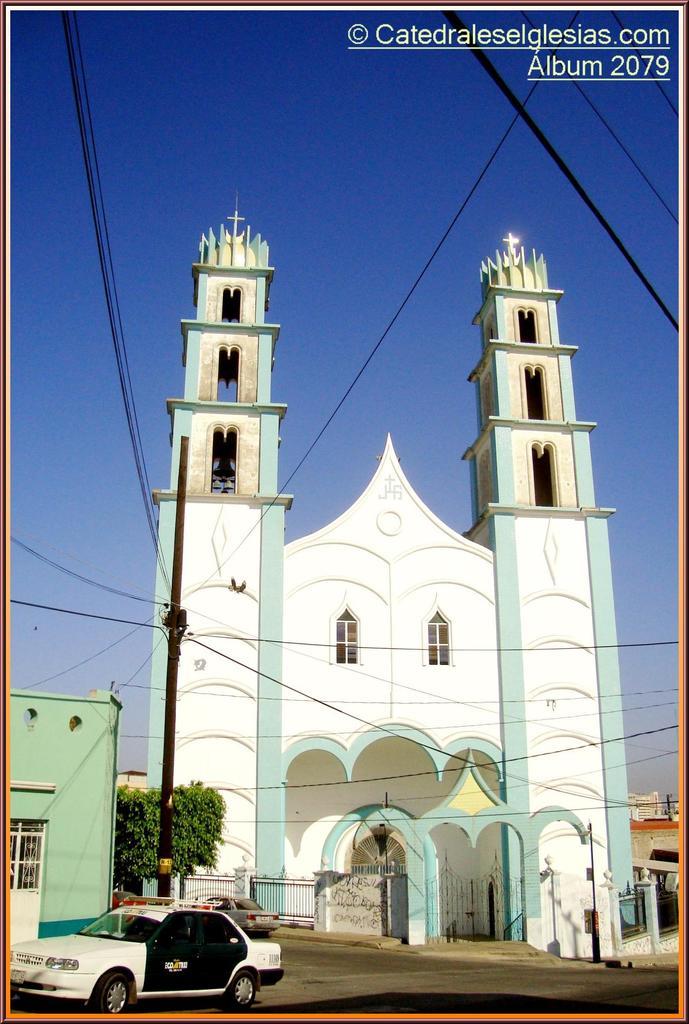What is the number after the word "album"?
Offer a terse response. 2079. 